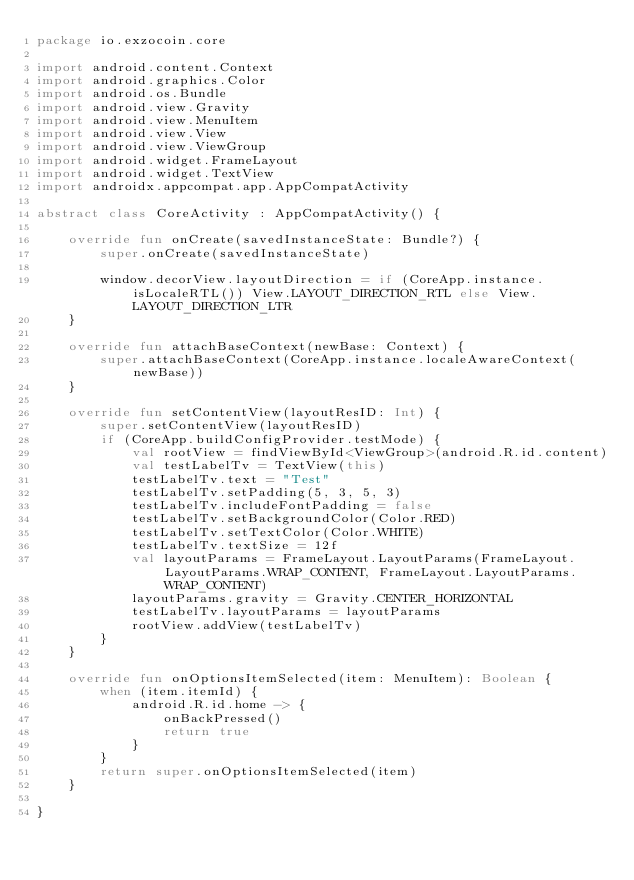<code> <loc_0><loc_0><loc_500><loc_500><_Kotlin_>package io.exzocoin.core

import android.content.Context
import android.graphics.Color
import android.os.Bundle
import android.view.Gravity
import android.view.MenuItem
import android.view.View
import android.view.ViewGroup
import android.widget.FrameLayout
import android.widget.TextView
import androidx.appcompat.app.AppCompatActivity

abstract class CoreActivity : AppCompatActivity() {

    override fun onCreate(savedInstanceState: Bundle?) {
        super.onCreate(savedInstanceState)

        window.decorView.layoutDirection = if (CoreApp.instance.isLocaleRTL()) View.LAYOUT_DIRECTION_RTL else View.LAYOUT_DIRECTION_LTR
    }

    override fun attachBaseContext(newBase: Context) {
        super.attachBaseContext(CoreApp.instance.localeAwareContext(newBase))
    }

    override fun setContentView(layoutResID: Int) {
        super.setContentView(layoutResID)
        if (CoreApp.buildConfigProvider.testMode) {
            val rootView = findViewById<ViewGroup>(android.R.id.content)
            val testLabelTv = TextView(this)
            testLabelTv.text = "Test"
            testLabelTv.setPadding(5, 3, 5, 3)
            testLabelTv.includeFontPadding = false
            testLabelTv.setBackgroundColor(Color.RED)
            testLabelTv.setTextColor(Color.WHITE)
            testLabelTv.textSize = 12f
            val layoutParams = FrameLayout.LayoutParams(FrameLayout.LayoutParams.WRAP_CONTENT, FrameLayout.LayoutParams.WRAP_CONTENT)
            layoutParams.gravity = Gravity.CENTER_HORIZONTAL
            testLabelTv.layoutParams = layoutParams
            rootView.addView(testLabelTv)
        }
    }

    override fun onOptionsItemSelected(item: MenuItem): Boolean {
        when (item.itemId) {
            android.R.id.home -> {
                onBackPressed()
                return true
            }
        }
        return super.onOptionsItemSelected(item)
    }

}
</code> 